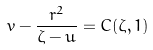<formula> <loc_0><loc_0><loc_500><loc_500>v - \frac { r ^ { 2 } } { \zeta - u } = C ( \zeta , 1 )</formula> 